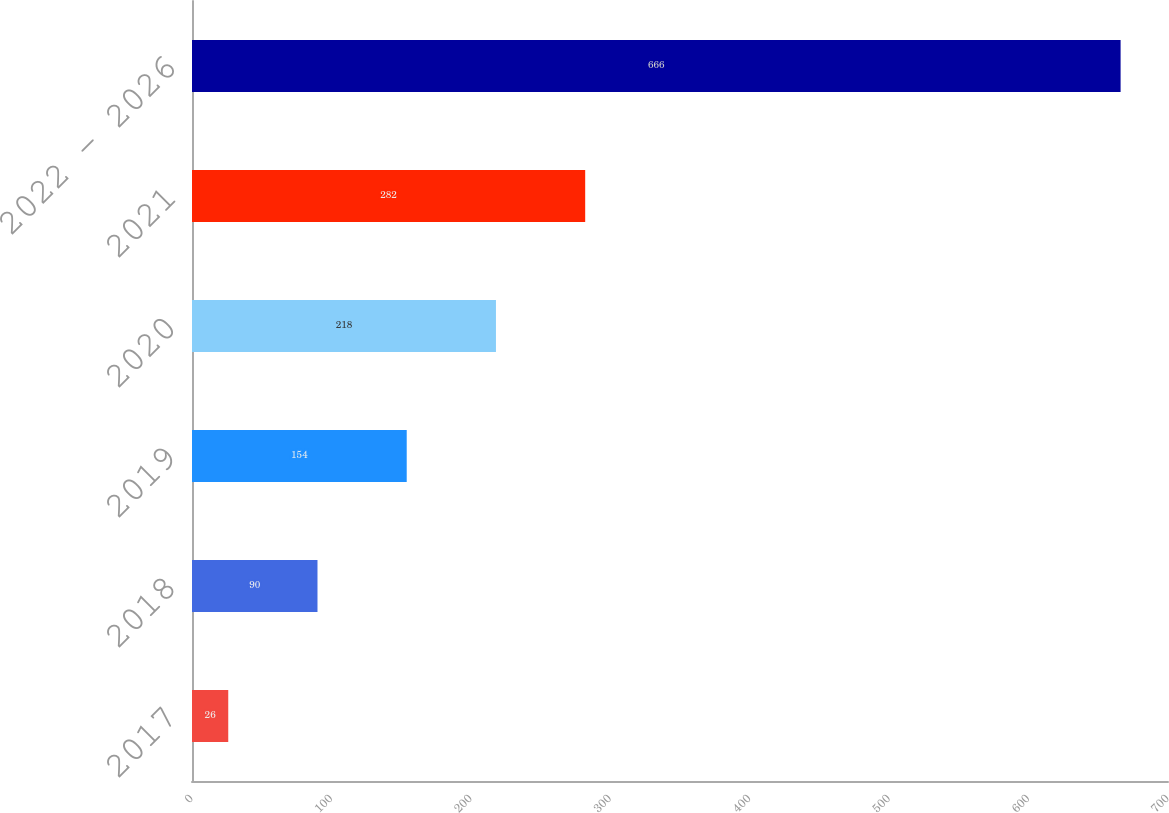Convert chart. <chart><loc_0><loc_0><loc_500><loc_500><bar_chart><fcel>2017<fcel>2018<fcel>2019<fcel>2020<fcel>2021<fcel>2022 - 2026<nl><fcel>26<fcel>90<fcel>154<fcel>218<fcel>282<fcel>666<nl></chart> 